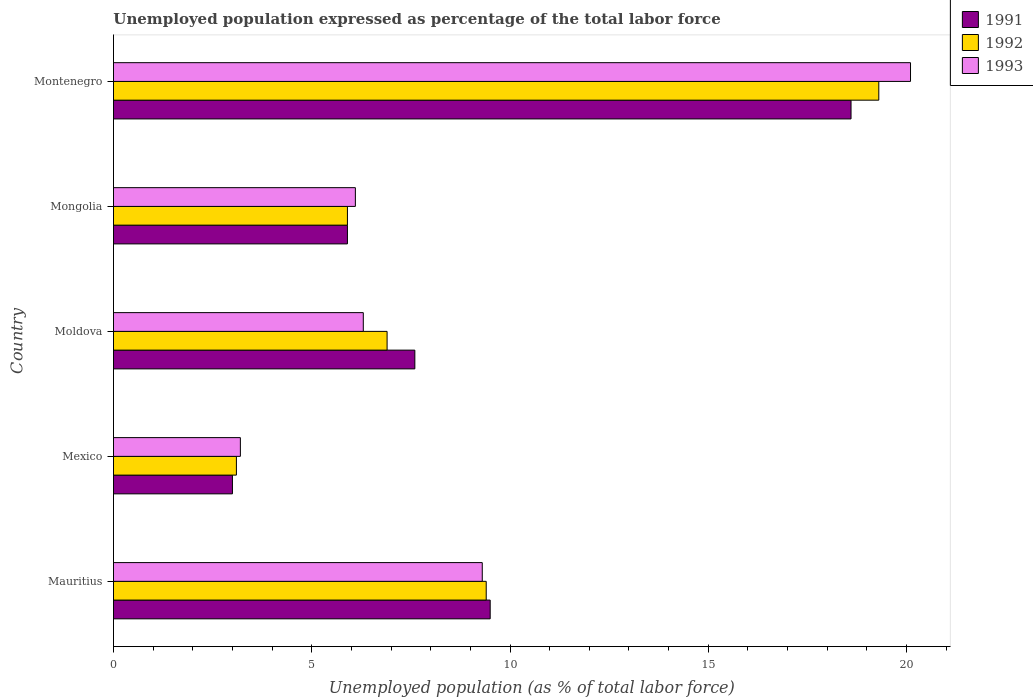How many different coloured bars are there?
Your answer should be compact. 3. How many groups of bars are there?
Your answer should be compact. 5. Are the number of bars per tick equal to the number of legend labels?
Your answer should be compact. Yes. What is the label of the 2nd group of bars from the top?
Provide a succinct answer. Mongolia. What is the unemployment in in 1991 in Mauritius?
Keep it short and to the point. 9.5. Across all countries, what is the maximum unemployment in in 1993?
Offer a terse response. 20.1. Across all countries, what is the minimum unemployment in in 1993?
Give a very brief answer. 3.2. In which country was the unemployment in in 1992 maximum?
Offer a terse response. Montenegro. In which country was the unemployment in in 1992 minimum?
Your response must be concise. Mexico. What is the total unemployment in in 1993 in the graph?
Ensure brevity in your answer.  45. What is the difference between the unemployment in in 1992 in Mauritius and that in Mongolia?
Offer a terse response. 3.5. What is the difference between the unemployment in in 1993 in Mauritius and the unemployment in in 1991 in Montenegro?
Make the answer very short. -9.3. What is the average unemployment in in 1991 per country?
Offer a very short reply. 8.92. What is the difference between the unemployment in in 1991 and unemployment in in 1992 in Mauritius?
Ensure brevity in your answer.  0.1. What is the ratio of the unemployment in in 1991 in Mauritius to that in Montenegro?
Provide a short and direct response. 0.51. Is the unemployment in in 1992 in Mexico less than that in Mongolia?
Provide a succinct answer. Yes. Is the difference between the unemployment in in 1991 in Mexico and Montenegro greater than the difference between the unemployment in in 1992 in Mexico and Montenegro?
Give a very brief answer. Yes. What is the difference between the highest and the second highest unemployment in in 1991?
Keep it short and to the point. 9.1. What is the difference between the highest and the lowest unemployment in in 1991?
Your answer should be very brief. 15.6. Is the sum of the unemployment in in 1992 in Mexico and Montenegro greater than the maximum unemployment in in 1993 across all countries?
Offer a very short reply. Yes. What does the 2nd bar from the bottom in Mongolia represents?
Ensure brevity in your answer.  1992. Are all the bars in the graph horizontal?
Offer a terse response. Yes. Are the values on the major ticks of X-axis written in scientific E-notation?
Make the answer very short. No. Does the graph contain grids?
Give a very brief answer. No. Where does the legend appear in the graph?
Your answer should be compact. Top right. How are the legend labels stacked?
Provide a succinct answer. Vertical. What is the title of the graph?
Your answer should be very brief. Unemployed population expressed as percentage of the total labor force. What is the label or title of the X-axis?
Offer a very short reply. Unemployed population (as % of total labor force). What is the Unemployed population (as % of total labor force) in 1991 in Mauritius?
Your answer should be very brief. 9.5. What is the Unemployed population (as % of total labor force) in 1992 in Mauritius?
Make the answer very short. 9.4. What is the Unemployed population (as % of total labor force) in 1993 in Mauritius?
Make the answer very short. 9.3. What is the Unemployed population (as % of total labor force) of 1992 in Mexico?
Ensure brevity in your answer.  3.1. What is the Unemployed population (as % of total labor force) in 1993 in Mexico?
Provide a short and direct response. 3.2. What is the Unemployed population (as % of total labor force) in 1991 in Moldova?
Make the answer very short. 7.6. What is the Unemployed population (as % of total labor force) of 1992 in Moldova?
Offer a very short reply. 6.9. What is the Unemployed population (as % of total labor force) of 1993 in Moldova?
Your response must be concise. 6.3. What is the Unemployed population (as % of total labor force) in 1991 in Mongolia?
Offer a terse response. 5.9. What is the Unemployed population (as % of total labor force) of 1992 in Mongolia?
Make the answer very short. 5.9. What is the Unemployed population (as % of total labor force) in 1993 in Mongolia?
Keep it short and to the point. 6.1. What is the Unemployed population (as % of total labor force) of 1991 in Montenegro?
Offer a terse response. 18.6. What is the Unemployed population (as % of total labor force) in 1992 in Montenegro?
Offer a terse response. 19.3. What is the Unemployed population (as % of total labor force) of 1993 in Montenegro?
Offer a terse response. 20.1. Across all countries, what is the maximum Unemployed population (as % of total labor force) in 1991?
Your answer should be very brief. 18.6. Across all countries, what is the maximum Unemployed population (as % of total labor force) of 1992?
Offer a very short reply. 19.3. Across all countries, what is the maximum Unemployed population (as % of total labor force) in 1993?
Keep it short and to the point. 20.1. Across all countries, what is the minimum Unemployed population (as % of total labor force) in 1991?
Provide a short and direct response. 3. Across all countries, what is the minimum Unemployed population (as % of total labor force) of 1992?
Keep it short and to the point. 3.1. Across all countries, what is the minimum Unemployed population (as % of total labor force) of 1993?
Your answer should be very brief. 3.2. What is the total Unemployed population (as % of total labor force) of 1991 in the graph?
Provide a short and direct response. 44.6. What is the total Unemployed population (as % of total labor force) in 1992 in the graph?
Your answer should be very brief. 44.6. What is the difference between the Unemployed population (as % of total labor force) in 1991 in Mauritius and that in Mexico?
Your response must be concise. 6.5. What is the difference between the Unemployed population (as % of total labor force) in 1991 in Mauritius and that in Moldova?
Provide a short and direct response. 1.9. What is the difference between the Unemployed population (as % of total labor force) of 1991 in Mauritius and that in Mongolia?
Your answer should be compact. 3.6. What is the difference between the Unemployed population (as % of total labor force) in 1992 in Mauritius and that in Mongolia?
Your response must be concise. 3.5. What is the difference between the Unemployed population (as % of total labor force) in 1993 in Mauritius and that in Mongolia?
Your answer should be very brief. 3.2. What is the difference between the Unemployed population (as % of total labor force) of 1992 in Mauritius and that in Montenegro?
Your response must be concise. -9.9. What is the difference between the Unemployed population (as % of total labor force) of 1991 in Mexico and that in Moldova?
Offer a terse response. -4.6. What is the difference between the Unemployed population (as % of total labor force) of 1993 in Mexico and that in Moldova?
Ensure brevity in your answer.  -3.1. What is the difference between the Unemployed population (as % of total labor force) in 1991 in Mexico and that in Mongolia?
Keep it short and to the point. -2.9. What is the difference between the Unemployed population (as % of total labor force) of 1992 in Mexico and that in Mongolia?
Provide a short and direct response. -2.8. What is the difference between the Unemployed population (as % of total labor force) of 1991 in Mexico and that in Montenegro?
Make the answer very short. -15.6. What is the difference between the Unemployed population (as % of total labor force) in 1992 in Mexico and that in Montenegro?
Ensure brevity in your answer.  -16.2. What is the difference between the Unemployed population (as % of total labor force) in 1993 in Mexico and that in Montenegro?
Your answer should be very brief. -16.9. What is the difference between the Unemployed population (as % of total labor force) in 1991 in Moldova and that in Mongolia?
Provide a succinct answer. 1.7. What is the difference between the Unemployed population (as % of total labor force) in 1992 in Moldova and that in Mongolia?
Provide a short and direct response. 1. What is the difference between the Unemployed population (as % of total labor force) in 1993 in Moldova and that in Mongolia?
Your response must be concise. 0.2. What is the difference between the Unemployed population (as % of total labor force) in 1992 in Moldova and that in Montenegro?
Keep it short and to the point. -12.4. What is the difference between the Unemployed population (as % of total labor force) of 1991 in Mongolia and that in Montenegro?
Your response must be concise. -12.7. What is the difference between the Unemployed population (as % of total labor force) of 1993 in Mongolia and that in Montenegro?
Provide a succinct answer. -14. What is the difference between the Unemployed population (as % of total labor force) of 1991 in Mauritius and the Unemployed population (as % of total labor force) of 1992 in Mexico?
Your answer should be compact. 6.4. What is the difference between the Unemployed population (as % of total labor force) in 1991 in Mauritius and the Unemployed population (as % of total labor force) in 1993 in Mexico?
Your response must be concise. 6.3. What is the difference between the Unemployed population (as % of total labor force) in 1992 in Mauritius and the Unemployed population (as % of total labor force) in 1993 in Mexico?
Your answer should be very brief. 6.2. What is the difference between the Unemployed population (as % of total labor force) of 1991 in Mauritius and the Unemployed population (as % of total labor force) of 1992 in Moldova?
Offer a very short reply. 2.6. What is the difference between the Unemployed population (as % of total labor force) of 1991 in Mauritius and the Unemployed population (as % of total labor force) of 1992 in Mongolia?
Provide a short and direct response. 3.6. What is the difference between the Unemployed population (as % of total labor force) of 1991 in Mexico and the Unemployed population (as % of total labor force) of 1992 in Moldova?
Your response must be concise. -3.9. What is the difference between the Unemployed population (as % of total labor force) in 1992 in Mexico and the Unemployed population (as % of total labor force) in 1993 in Moldova?
Your answer should be very brief. -3.2. What is the difference between the Unemployed population (as % of total labor force) of 1991 in Mexico and the Unemployed population (as % of total labor force) of 1992 in Montenegro?
Ensure brevity in your answer.  -16.3. What is the difference between the Unemployed population (as % of total labor force) in 1991 in Mexico and the Unemployed population (as % of total labor force) in 1993 in Montenegro?
Keep it short and to the point. -17.1. What is the difference between the Unemployed population (as % of total labor force) of 1992 in Mexico and the Unemployed population (as % of total labor force) of 1993 in Montenegro?
Provide a short and direct response. -17. What is the difference between the Unemployed population (as % of total labor force) of 1991 in Moldova and the Unemployed population (as % of total labor force) of 1992 in Mongolia?
Provide a short and direct response. 1.7. What is the difference between the Unemployed population (as % of total labor force) of 1991 in Moldova and the Unemployed population (as % of total labor force) of 1993 in Mongolia?
Make the answer very short. 1.5. What is the difference between the Unemployed population (as % of total labor force) of 1991 in Mongolia and the Unemployed population (as % of total labor force) of 1993 in Montenegro?
Your answer should be very brief. -14.2. What is the difference between the Unemployed population (as % of total labor force) of 1992 in Mongolia and the Unemployed population (as % of total labor force) of 1993 in Montenegro?
Your answer should be compact. -14.2. What is the average Unemployed population (as % of total labor force) in 1991 per country?
Your answer should be compact. 8.92. What is the average Unemployed population (as % of total labor force) of 1992 per country?
Give a very brief answer. 8.92. What is the difference between the Unemployed population (as % of total labor force) of 1991 and Unemployed population (as % of total labor force) of 1993 in Mauritius?
Make the answer very short. 0.2. What is the difference between the Unemployed population (as % of total labor force) of 1991 and Unemployed population (as % of total labor force) of 1992 in Mexico?
Ensure brevity in your answer.  -0.1. What is the difference between the Unemployed population (as % of total labor force) of 1992 and Unemployed population (as % of total labor force) of 1993 in Mexico?
Keep it short and to the point. -0.1. What is the difference between the Unemployed population (as % of total labor force) in 1991 and Unemployed population (as % of total labor force) in 1993 in Moldova?
Offer a terse response. 1.3. What is the difference between the Unemployed population (as % of total labor force) of 1992 and Unemployed population (as % of total labor force) of 1993 in Moldova?
Offer a very short reply. 0.6. What is the difference between the Unemployed population (as % of total labor force) of 1991 and Unemployed population (as % of total labor force) of 1992 in Montenegro?
Make the answer very short. -0.7. What is the ratio of the Unemployed population (as % of total labor force) of 1991 in Mauritius to that in Mexico?
Offer a terse response. 3.17. What is the ratio of the Unemployed population (as % of total labor force) of 1992 in Mauritius to that in Mexico?
Offer a terse response. 3.03. What is the ratio of the Unemployed population (as % of total labor force) in 1993 in Mauritius to that in Mexico?
Make the answer very short. 2.91. What is the ratio of the Unemployed population (as % of total labor force) in 1991 in Mauritius to that in Moldova?
Your response must be concise. 1.25. What is the ratio of the Unemployed population (as % of total labor force) in 1992 in Mauritius to that in Moldova?
Ensure brevity in your answer.  1.36. What is the ratio of the Unemployed population (as % of total labor force) in 1993 in Mauritius to that in Moldova?
Your answer should be very brief. 1.48. What is the ratio of the Unemployed population (as % of total labor force) in 1991 in Mauritius to that in Mongolia?
Offer a very short reply. 1.61. What is the ratio of the Unemployed population (as % of total labor force) in 1992 in Mauritius to that in Mongolia?
Ensure brevity in your answer.  1.59. What is the ratio of the Unemployed population (as % of total labor force) of 1993 in Mauritius to that in Mongolia?
Make the answer very short. 1.52. What is the ratio of the Unemployed population (as % of total labor force) in 1991 in Mauritius to that in Montenegro?
Offer a very short reply. 0.51. What is the ratio of the Unemployed population (as % of total labor force) in 1992 in Mauritius to that in Montenegro?
Make the answer very short. 0.49. What is the ratio of the Unemployed population (as % of total labor force) of 1993 in Mauritius to that in Montenegro?
Offer a terse response. 0.46. What is the ratio of the Unemployed population (as % of total labor force) of 1991 in Mexico to that in Moldova?
Your answer should be very brief. 0.39. What is the ratio of the Unemployed population (as % of total labor force) in 1992 in Mexico to that in Moldova?
Make the answer very short. 0.45. What is the ratio of the Unemployed population (as % of total labor force) in 1993 in Mexico to that in Moldova?
Provide a short and direct response. 0.51. What is the ratio of the Unemployed population (as % of total labor force) of 1991 in Mexico to that in Mongolia?
Offer a very short reply. 0.51. What is the ratio of the Unemployed population (as % of total labor force) of 1992 in Mexico to that in Mongolia?
Your answer should be compact. 0.53. What is the ratio of the Unemployed population (as % of total labor force) of 1993 in Mexico to that in Mongolia?
Ensure brevity in your answer.  0.52. What is the ratio of the Unemployed population (as % of total labor force) in 1991 in Mexico to that in Montenegro?
Provide a succinct answer. 0.16. What is the ratio of the Unemployed population (as % of total labor force) in 1992 in Mexico to that in Montenegro?
Give a very brief answer. 0.16. What is the ratio of the Unemployed population (as % of total labor force) of 1993 in Mexico to that in Montenegro?
Your answer should be very brief. 0.16. What is the ratio of the Unemployed population (as % of total labor force) of 1991 in Moldova to that in Mongolia?
Ensure brevity in your answer.  1.29. What is the ratio of the Unemployed population (as % of total labor force) in 1992 in Moldova to that in Mongolia?
Ensure brevity in your answer.  1.17. What is the ratio of the Unemployed population (as % of total labor force) in 1993 in Moldova to that in Mongolia?
Your response must be concise. 1.03. What is the ratio of the Unemployed population (as % of total labor force) in 1991 in Moldova to that in Montenegro?
Provide a succinct answer. 0.41. What is the ratio of the Unemployed population (as % of total labor force) of 1992 in Moldova to that in Montenegro?
Your answer should be compact. 0.36. What is the ratio of the Unemployed population (as % of total labor force) in 1993 in Moldova to that in Montenegro?
Your answer should be very brief. 0.31. What is the ratio of the Unemployed population (as % of total labor force) in 1991 in Mongolia to that in Montenegro?
Provide a succinct answer. 0.32. What is the ratio of the Unemployed population (as % of total labor force) of 1992 in Mongolia to that in Montenegro?
Give a very brief answer. 0.31. What is the ratio of the Unemployed population (as % of total labor force) of 1993 in Mongolia to that in Montenegro?
Offer a terse response. 0.3. What is the difference between the highest and the second highest Unemployed population (as % of total labor force) in 1991?
Give a very brief answer. 9.1. What is the difference between the highest and the lowest Unemployed population (as % of total labor force) of 1992?
Your answer should be compact. 16.2. 